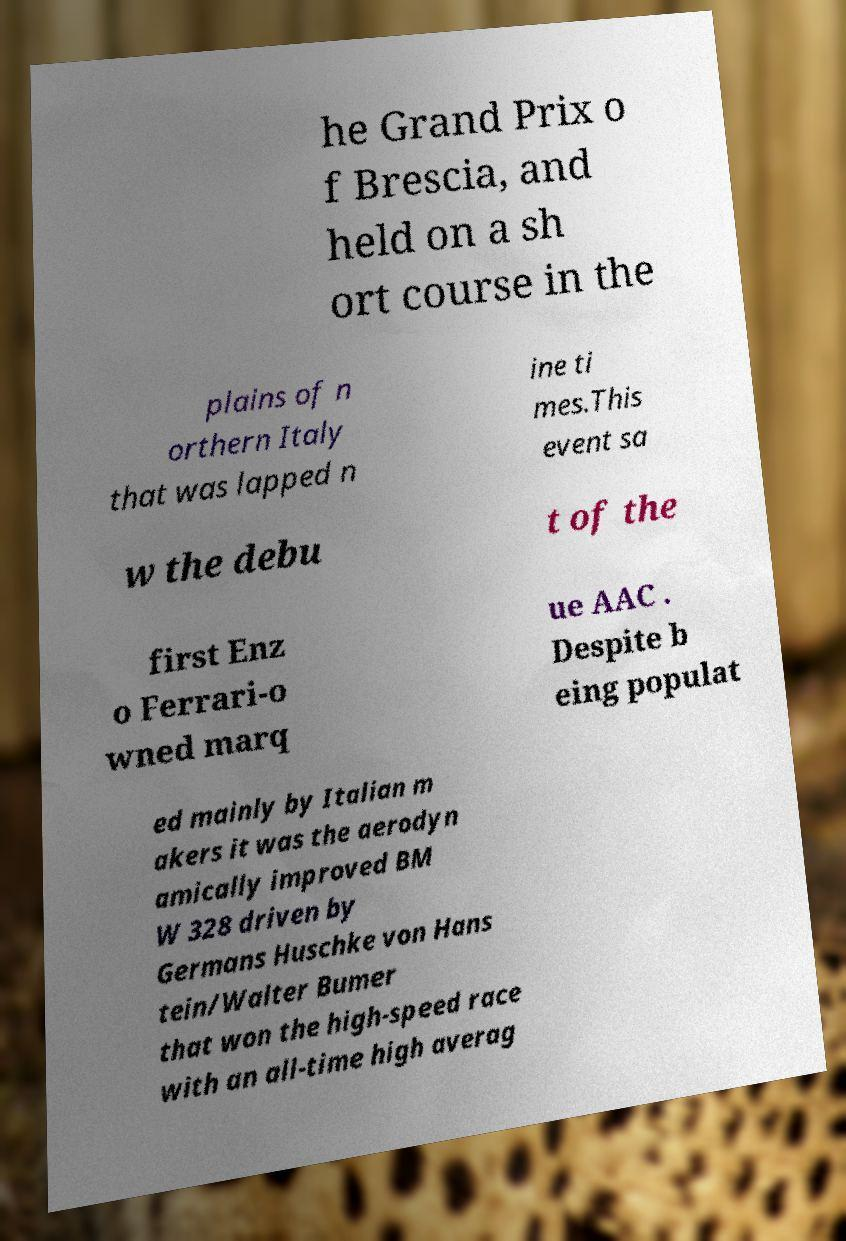Can you accurately transcribe the text from the provided image for me? he Grand Prix o f Brescia, and held on a sh ort course in the plains of n orthern Italy that was lapped n ine ti mes.This event sa w the debu t of the first Enz o Ferrari-o wned marq ue AAC . Despite b eing populat ed mainly by Italian m akers it was the aerodyn amically improved BM W 328 driven by Germans Huschke von Hans tein/Walter Bumer that won the high-speed race with an all-time high averag 